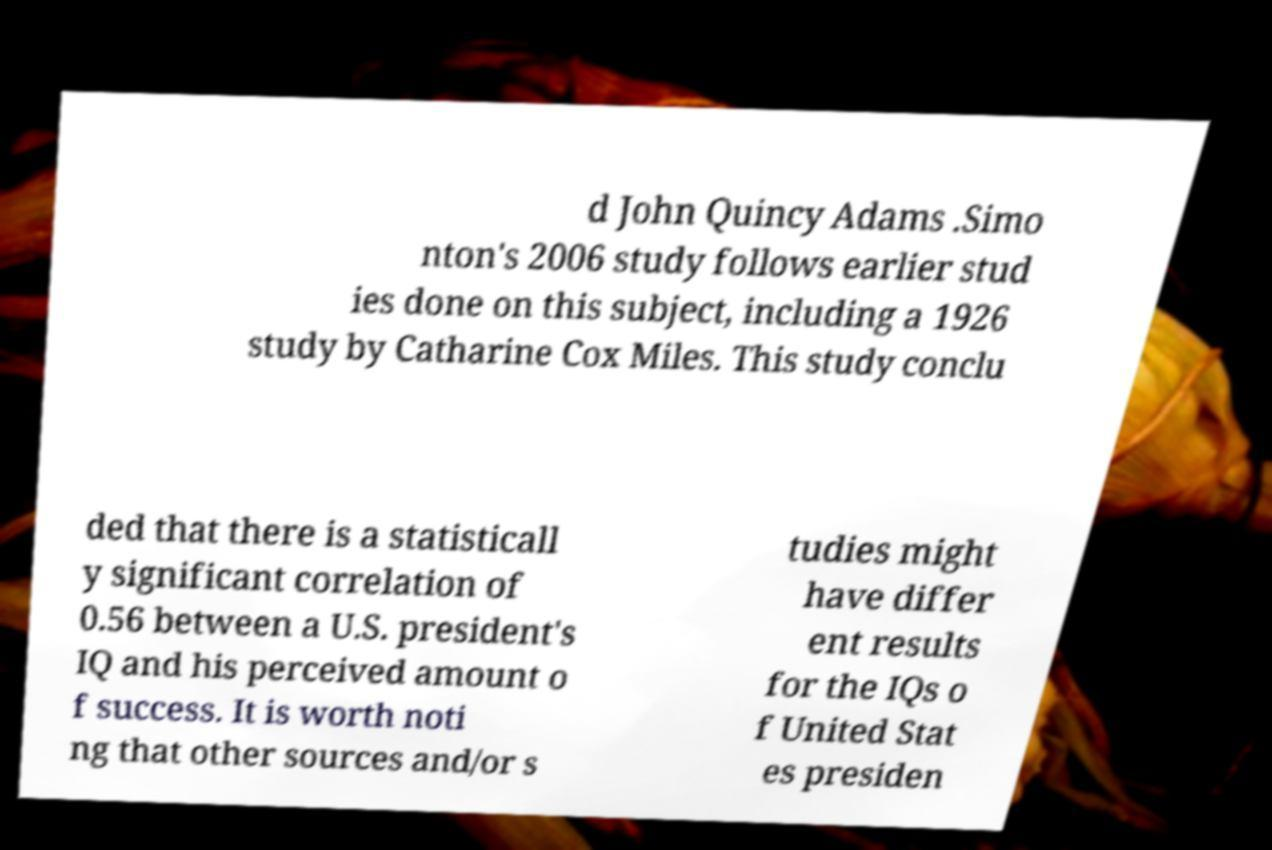Could you assist in decoding the text presented in this image and type it out clearly? d John Quincy Adams .Simo nton's 2006 study follows earlier stud ies done on this subject, including a 1926 study by Catharine Cox Miles. This study conclu ded that there is a statisticall y significant correlation of 0.56 between a U.S. president's IQ and his perceived amount o f success. It is worth noti ng that other sources and/or s tudies might have differ ent results for the IQs o f United Stat es presiden 